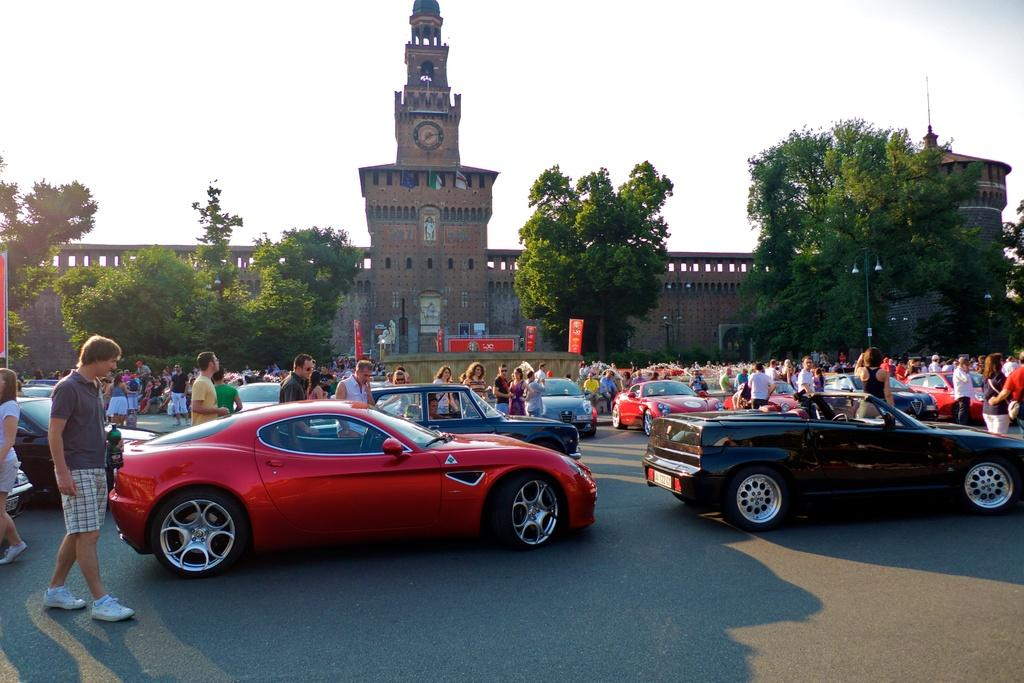What type of vehicles can be seen at the bottom of the image? There are cars on the road at the bottom of the image. Can you describe the people in the image? There are people in the image, but their specific actions or appearances are not mentioned in the facts. What is visible in the background of the image? There is a building, trees, and the sky visible in the background of the image. Are there any dinosaurs walking on the road in the image? No, there are no dinosaurs present in the image. Can you see a leg sticking out from the building in the image? There is no mention of a leg or any body part in the image; the facts only mention a building and other elements. 